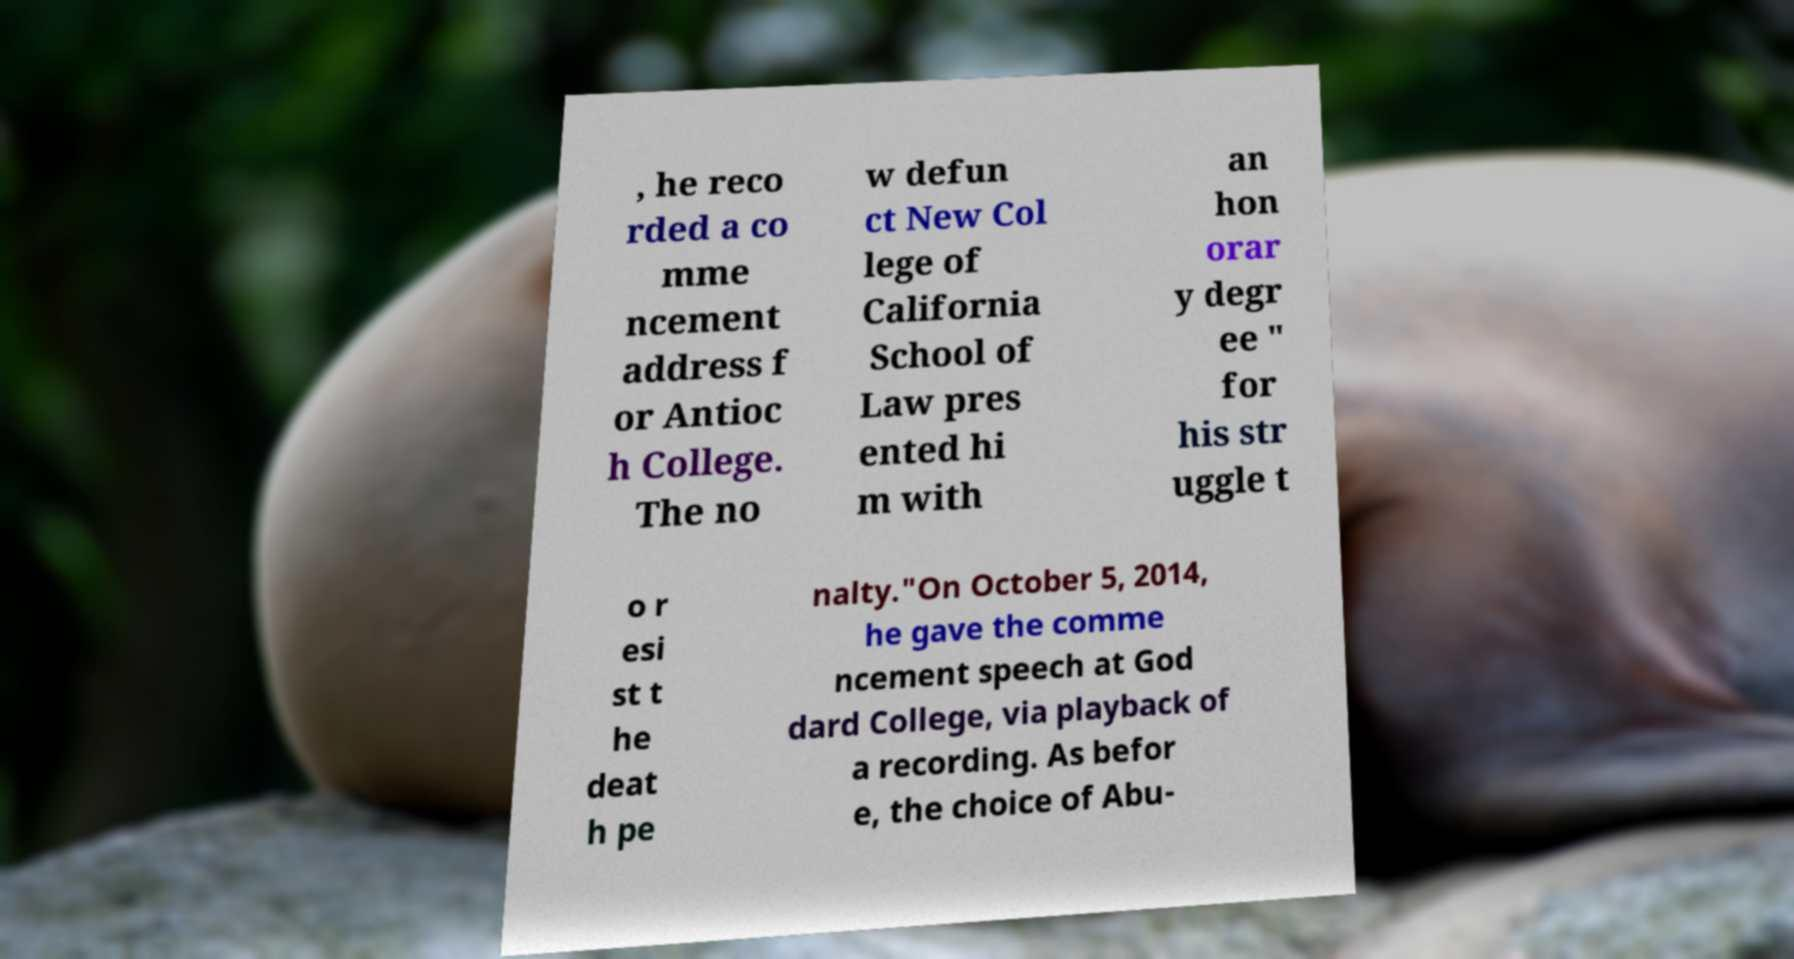Could you assist in decoding the text presented in this image and type it out clearly? , he reco rded a co mme ncement address f or Antioc h College. The no w defun ct New Col lege of California School of Law pres ented hi m with an hon orar y degr ee " for his str uggle t o r esi st t he deat h pe nalty."On October 5, 2014, he gave the comme ncement speech at God dard College, via playback of a recording. As befor e, the choice of Abu- 